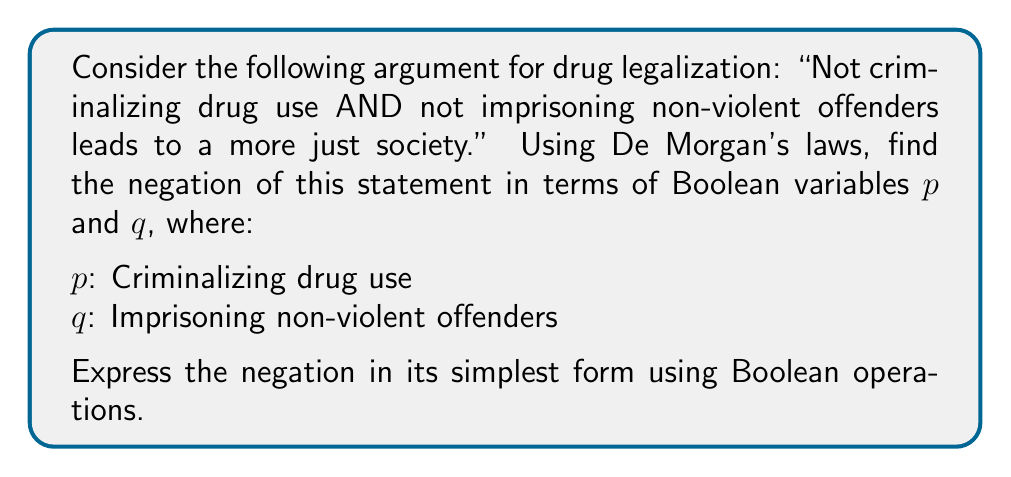Provide a solution to this math problem. Let's approach this step-by-step:

1) First, we need to express the original statement in Boolean algebra:
   $(\lnot p \land \lnot q) \rightarrow \text{more just society}$

2) We're interested in negating the left side of the implication:
   $\lnot(\lnot p \land \lnot q)$

3) This is where we apply De Morgan's law. The law states:
   $\lnot(A \land B) = \lnot A \lor \lnot B$

4) Applying this to our expression:
   $\lnot(\lnot p \land \lnot q) = \lnot(\lnot p) \lor \lnot(\lnot q)$

5) Now, we can simplify the double negations:
   $\lnot(\lnot p) = p$
   $\lnot(\lnot q) = q$

6) Therefore, our final simplified expression is:
   $p \lor q$

This means that the negation of the original argument is "Criminalizing drug use OR imprisoning non-violent offenders."
Answer: $p \lor q$ 